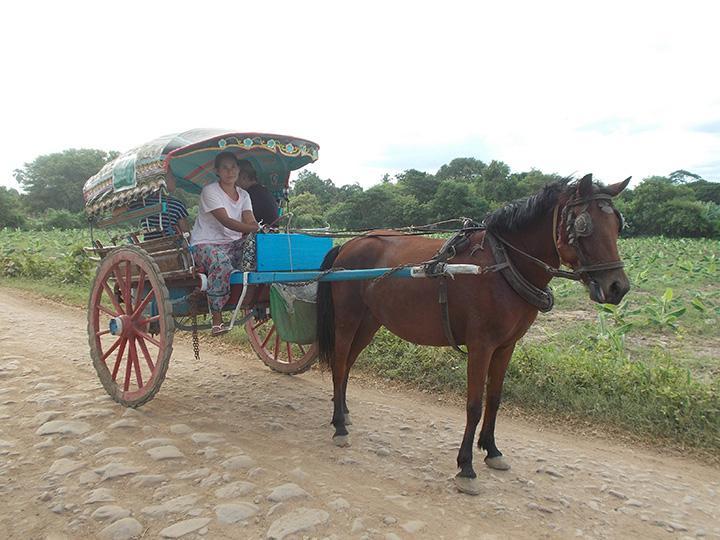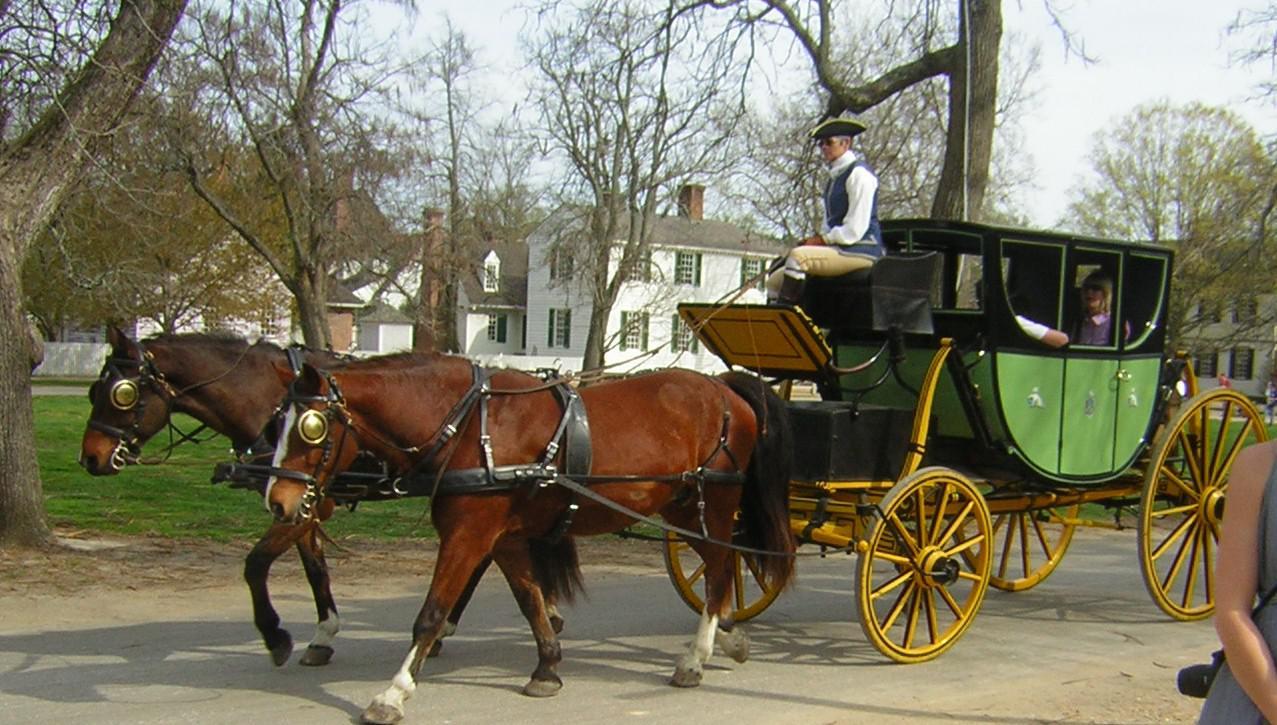The first image is the image on the left, the second image is the image on the right. For the images shown, is this caption "One image shows a leftward-facing pony with a white mane hitched to a two-wheeled cart carrying one woman in a hat." true? Answer yes or no. No. The first image is the image on the left, the second image is the image on the right. Analyze the images presented: Is the assertion "Horses are transporting people in both images." valid? Answer yes or no. Yes. 